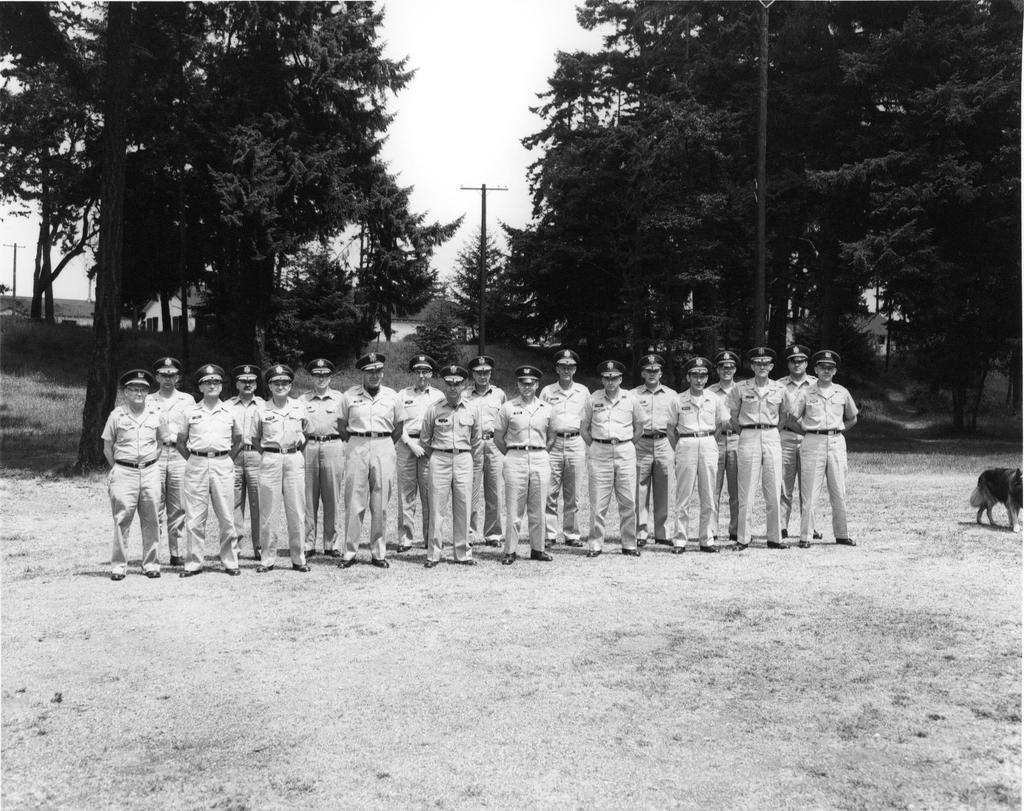How would you summarize this image in a sentence or two? In the picture I can see few police men standing and there is a dog in the right corner and there are few trees and poles in the background. 